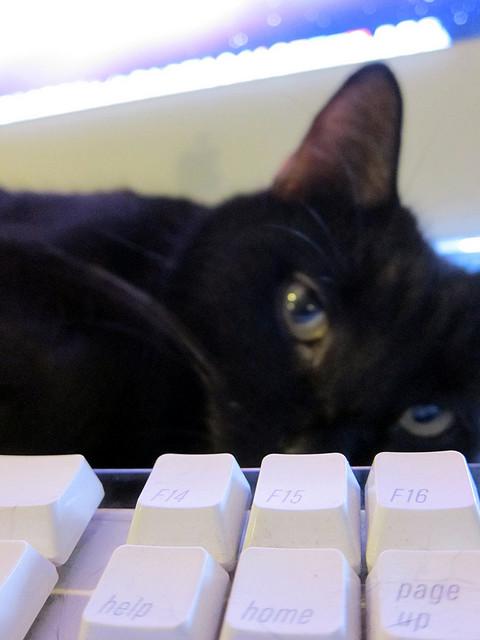What key is on the most bottom right part of the image?
Answer briefly. Page up. What is laying behind the keyboard?
Short answer required. Cat. What color is the cat?
Keep it brief. Black. 